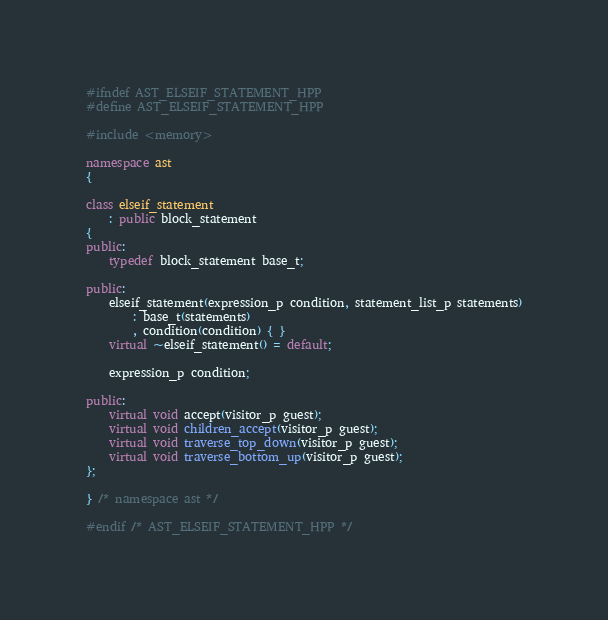<code> <loc_0><loc_0><loc_500><loc_500><_C++_>#ifndef AST_ELSEIF_STATEMENT_HPP
#define AST_ELSEIF_STATEMENT_HPP

#include <memory>

namespace ast
{

class elseif_statement
    : public block_statement
{
public:
    typedef block_statement base_t;

public:
    elseif_statement(expression_p condition, statement_list_p statements)
        : base_t(statements)
        , condition(condition) { }
    virtual ~elseif_statement() = default;

    expression_p condition;

public:
    virtual void accept(visitor_p guest);
    virtual void children_accept(visitor_p guest);
    virtual void traverse_top_down(visitor_p guest);
    virtual void traverse_bottom_up(visitor_p guest);
};

} /* namespace ast */

#endif /* AST_ELSEIF_STATEMENT_HPP */</code> 